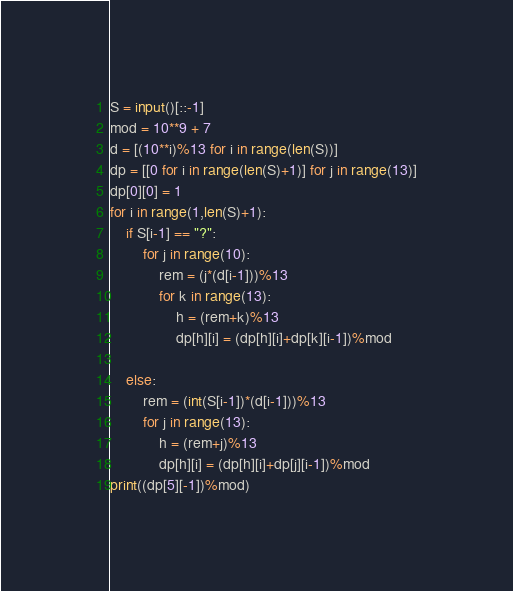Convert code to text. <code><loc_0><loc_0><loc_500><loc_500><_Python_>S = input()[::-1]
mod = 10**9 + 7
d = [(10**i)%13 for i in range(len(S))]
dp = [[0 for i in range(len(S)+1)] for j in range(13)]
dp[0][0] = 1
for i in range(1,len(S)+1):
    if S[i-1] == "?":
        for j in range(10):
            rem = (j*(d[i-1]))%13
            for k in range(13):
                h = (rem+k)%13
                dp[h][i] = (dp[h][i]+dp[k][i-1])%mod
        
    else:
        rem = (int(S[i-1])*(d[i-1]))%13
        for j in range(13):
            h = (rem+j)%13
            dp[h][i] = (dp[h][i]+dp[j][i-1])%mod
print((dp[5][-1])%mod)</code> 